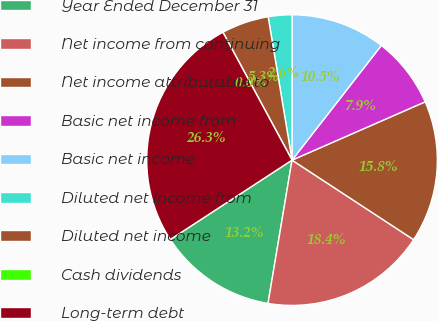Convert chart. <chart><loc_0><loc_0><loc_500><loc_500><pie_chart><fcel>Year Ended December 31<fcel>Net income from continuing<fcel>Net income attributable to<fcel>Basic net income from<fcel>Basic net income<fcel>Diluted net income from<fcel>Diluted net income<fcel>Cash dividends<fcel>Long-term debt<nl><fcel>13.16%<fcel>18.42%<fcel>15.79%<fcel>7.9%<fcel>10.53%<fcel>2.63%<fcel>5.26%<fcel>0.0%<fcel>26.31%<nl></chart> 